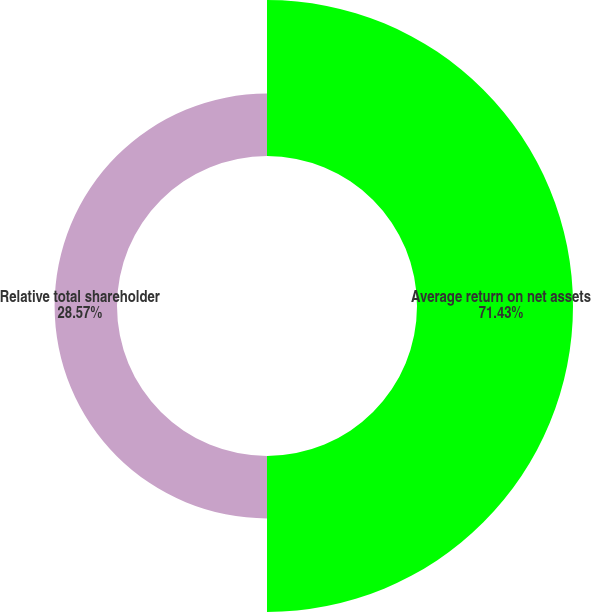<chart> <loc_0><loc_0><loc_500><loc_500><pie_chart><fcel>Average return on net assets<fcel>Relative total shareholder<nl><fcel>71.43%<fcel>28.57%<nl></chart> 